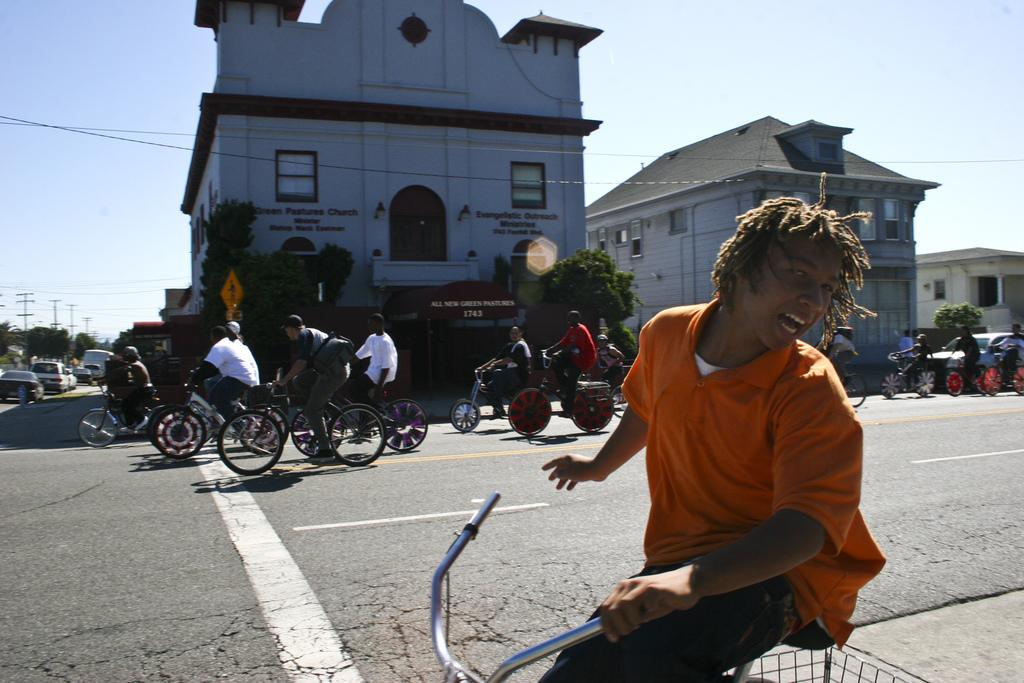What are the people in the image doing? People are riding bicycles on the road. What is behind the bicycles in the image? There are cars behind the bicycles. What can be seen in the background of the image? There are buildings and trees in the background. How many brothers are swimming in the beds in the image? There are no brothers or beds present in the image; it features people riding bicycles on the road with cars behind them and buildings and trees in the background. 